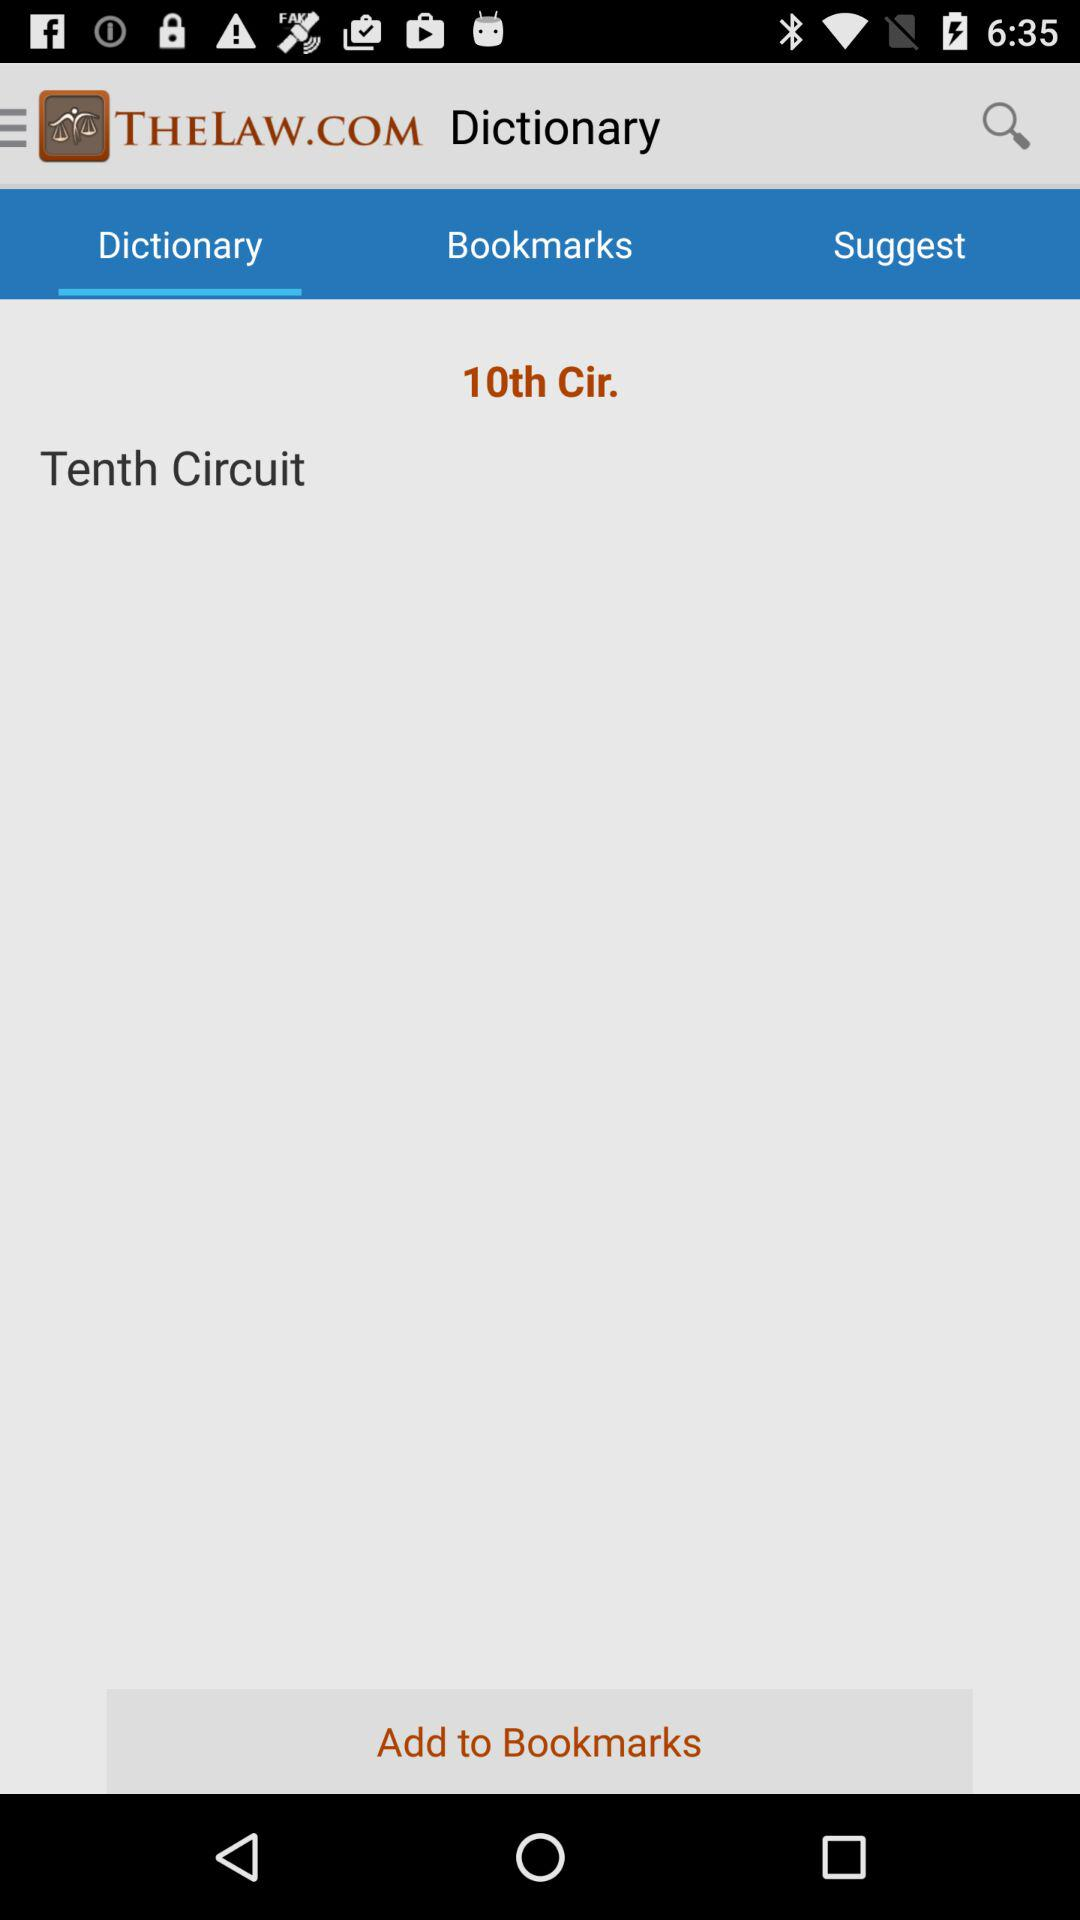Which word is written in the "Dictionary" option? The 'Dictionary' option displays the words 'Tenth Circuit,' which refer to a term used in legal contexts, likely representing one of the regional courts in the federal judicial system of the United States. 